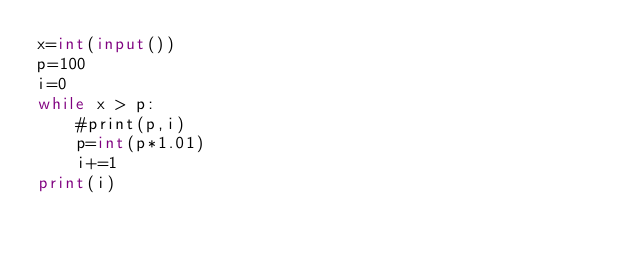Convert code to text. <code><loc_0><loc_0><loc_500><loc_500><_Python_>x=int(input())
p=100
i=0
while x > p:
    #print(p,i)
    p=int(p*1.01)
    i+=1
print(i)</code> 